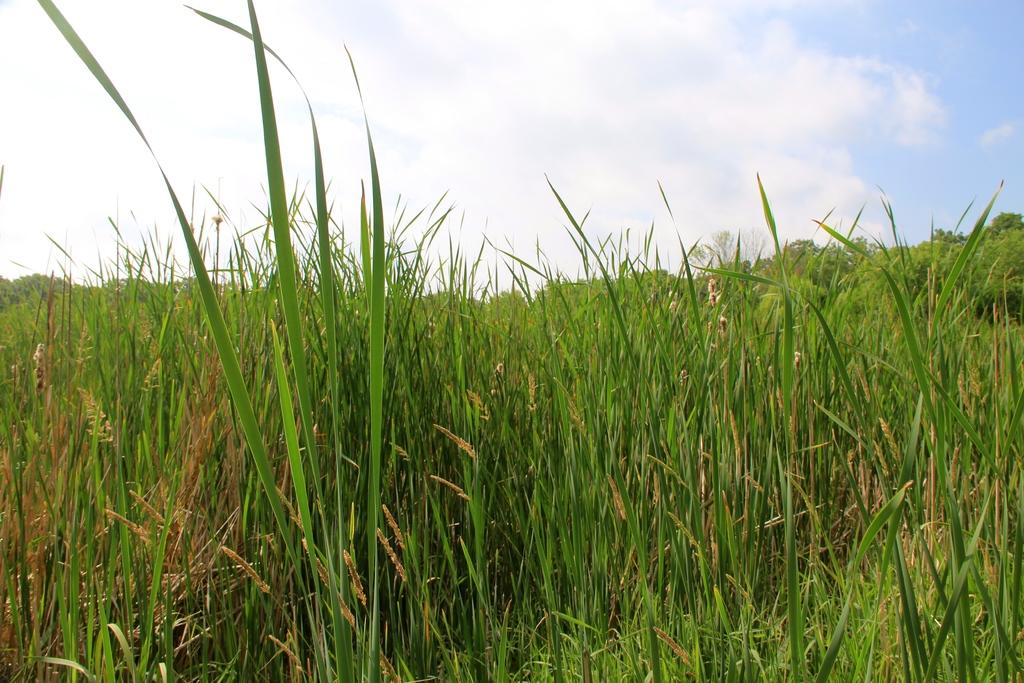What type of vegetation can be seen in the image? There is grass in the image, stretching from left to right. What color is the sky in the image? The sky is blue in color. Are there any clouds visible in the sky? Yes, the sky is cloudy in the image. What type of poison is being used to control the growth of the grass in the image? There is no mention of any poison being used to control the growth of the grass in the image. 